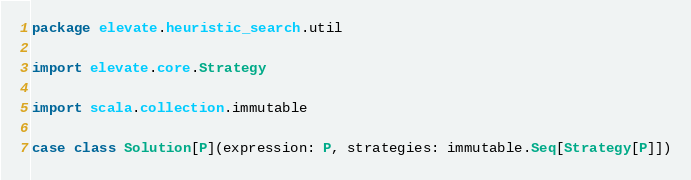<code> <loc_0><loc_0><loc_500><loc_500><_Scala_>package elevate.heuristic_search.util

import elevate.core.Strategy

import scala.collection.immutable

case class Solution[P](expression: P, strategies: immutable.Seq[Strategy[P]])
</code> 